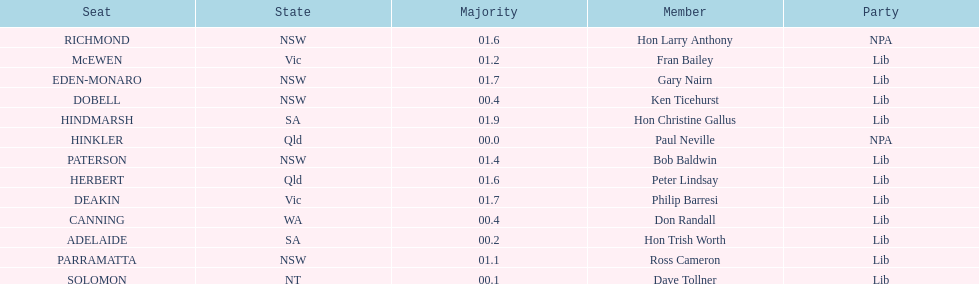Who is listed before don randall? Hon Trish Worth. Parse the table in full. {'header': ['Seat', 'State', 'Majority', 'Member', 'Party'], 'rows': [['RICHMOND', 'NSW', '01.6', 'Hon Larry Anthony', 'NPA'], ['McEWEN', 'Vic', '01.2', 'Fran Bailey', 'Lib'], ['EDEN-MONARO', 'NSW', '01.7', 'Gary Nairn', 'Lib'], ['DOBELL', 'NSW', '00.4', 'Ken Ticehurst', 'Lib'], ['HINDMARSH', 'SA', '01.9', 'Hon Christine Gallus', 'Lib'], ['HINKLER', 'Qld', '00.0', 'Paul Neville', 'NPA'], ['PATERSON', 'NSW', '01.4', 'Bob Baldwin', 'Lib'], ['HERBERT', 'Qld', '01.6', 'Peter Lindsay', 'Lib'], ['DEAKIN', 'Vic', '01.7', 'Philip Barresi', 'Lib'], ['CANNING', 'WA', '00.4', 'Don Randall', 'Lib'], ['ADELAIDE', 'SA', '00.2', 'Hon Trish Worth', 'Lib'], ['PARRAMATTA', 'NSW', '01.1', 'Ross Cameron', 'Lib'], ['SOLOMON', 'NT', '00.1', 'Dave Tollner', 'Lib']]} 